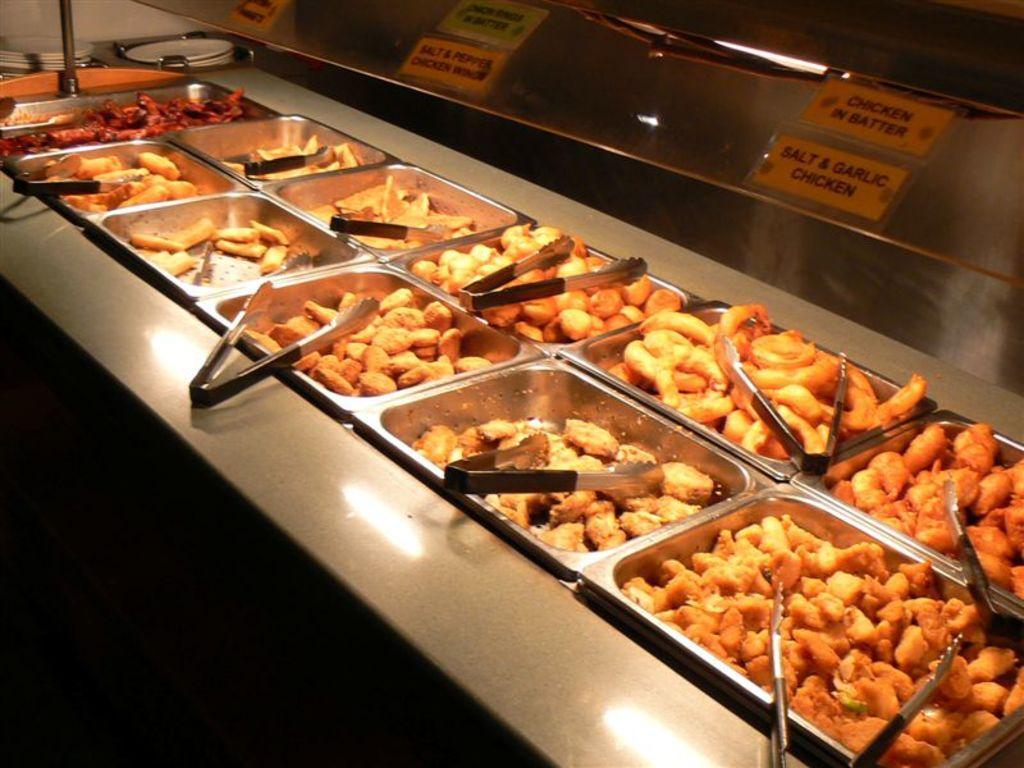Please provide a concise description of this image. In this image in the center there are some bowls in that bowls there are some food items and a spoons, and at the top there is one steel board. On the board there are some name papers. 